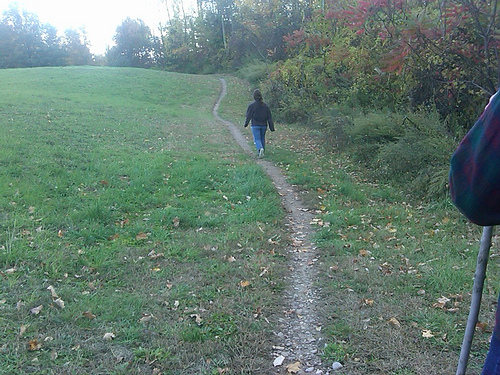<image>
Can you confirm if the girl is behind the grass? No. The girl is not behind the grass. From this viewpoint, the girl appears to be positioned elsewhere in the scene. 